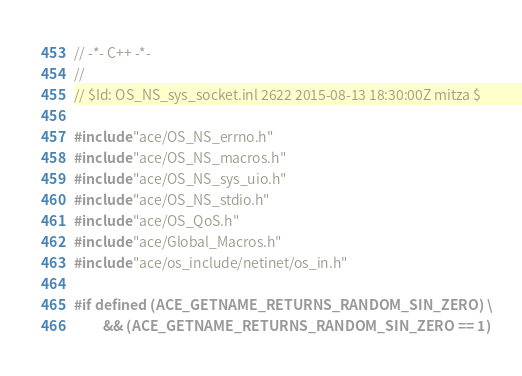<code> <loc_0><loc_0><loc_500><loc_500><_C++_>// -*- C++ -*-
//
// $Id: OS_NS_sys_socket.inl 2622 2015-08-13 18:30:00Z mitza $

#include "ace/OS_NS_errno.h"
#include "ace/OS_NS_macros.h"
#include "ace/OS_NS_sys_uio.h"
#include "ace/OS_NS_stdio.h"
#include "ace/OS_QoS.h"
#include "ace/Global_Macros.h"
#include "ace/os_include/netinet/os_in.h"

#if defined (ACE_GETNAME_RETURNS_RANDOM_SIN_ZERO) \
         && (ACE_GETNAME_RETURNS_RANDOM_SIN_ZERO == 1)</code> 